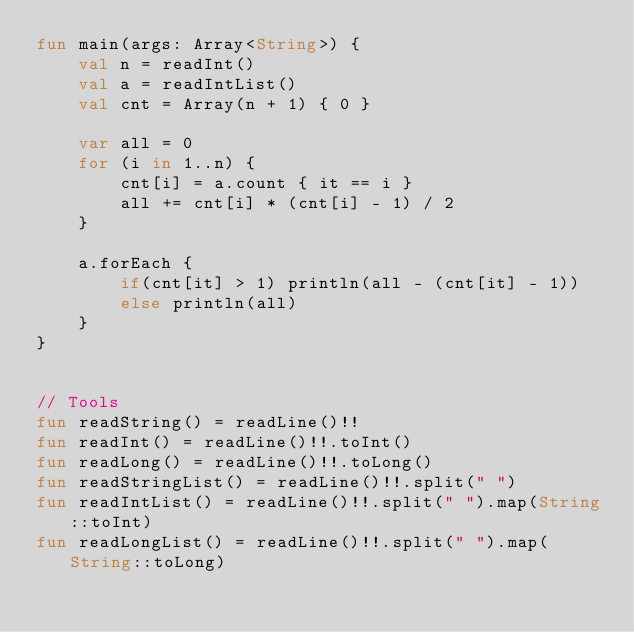<code> <loc_0><loc_0><loc_500><loc_500><_Kotlin_>fun main(args: Array<String>) {
    val n = readInt()
    val a = readIntList()
    val cnt = Array(n + 1) { 0 }

    var all = 0
    for (i in 1..n) {
        cnt[i] = a.count { it == i }
        all += cnt[i] * (cnt[i] - 1) / 2
    }

    a.forEach {
        if(cnt[it] > 1) println(all - (cnt[it] - 1))
        else println(all)
    }
}


// Tools
fun readString() = readLine()!!
fun readInt() = readLine()!!.toInt()
fun readLong() = readLine()!!.toLong()
fun readStringList() = readLine()!!.split(" ")
fun readIntList() = readLine()!!.split(" ").map(String::toInt)
fun readLongList() = readLine()!!.split(" ").map(String::toLong)</code> 